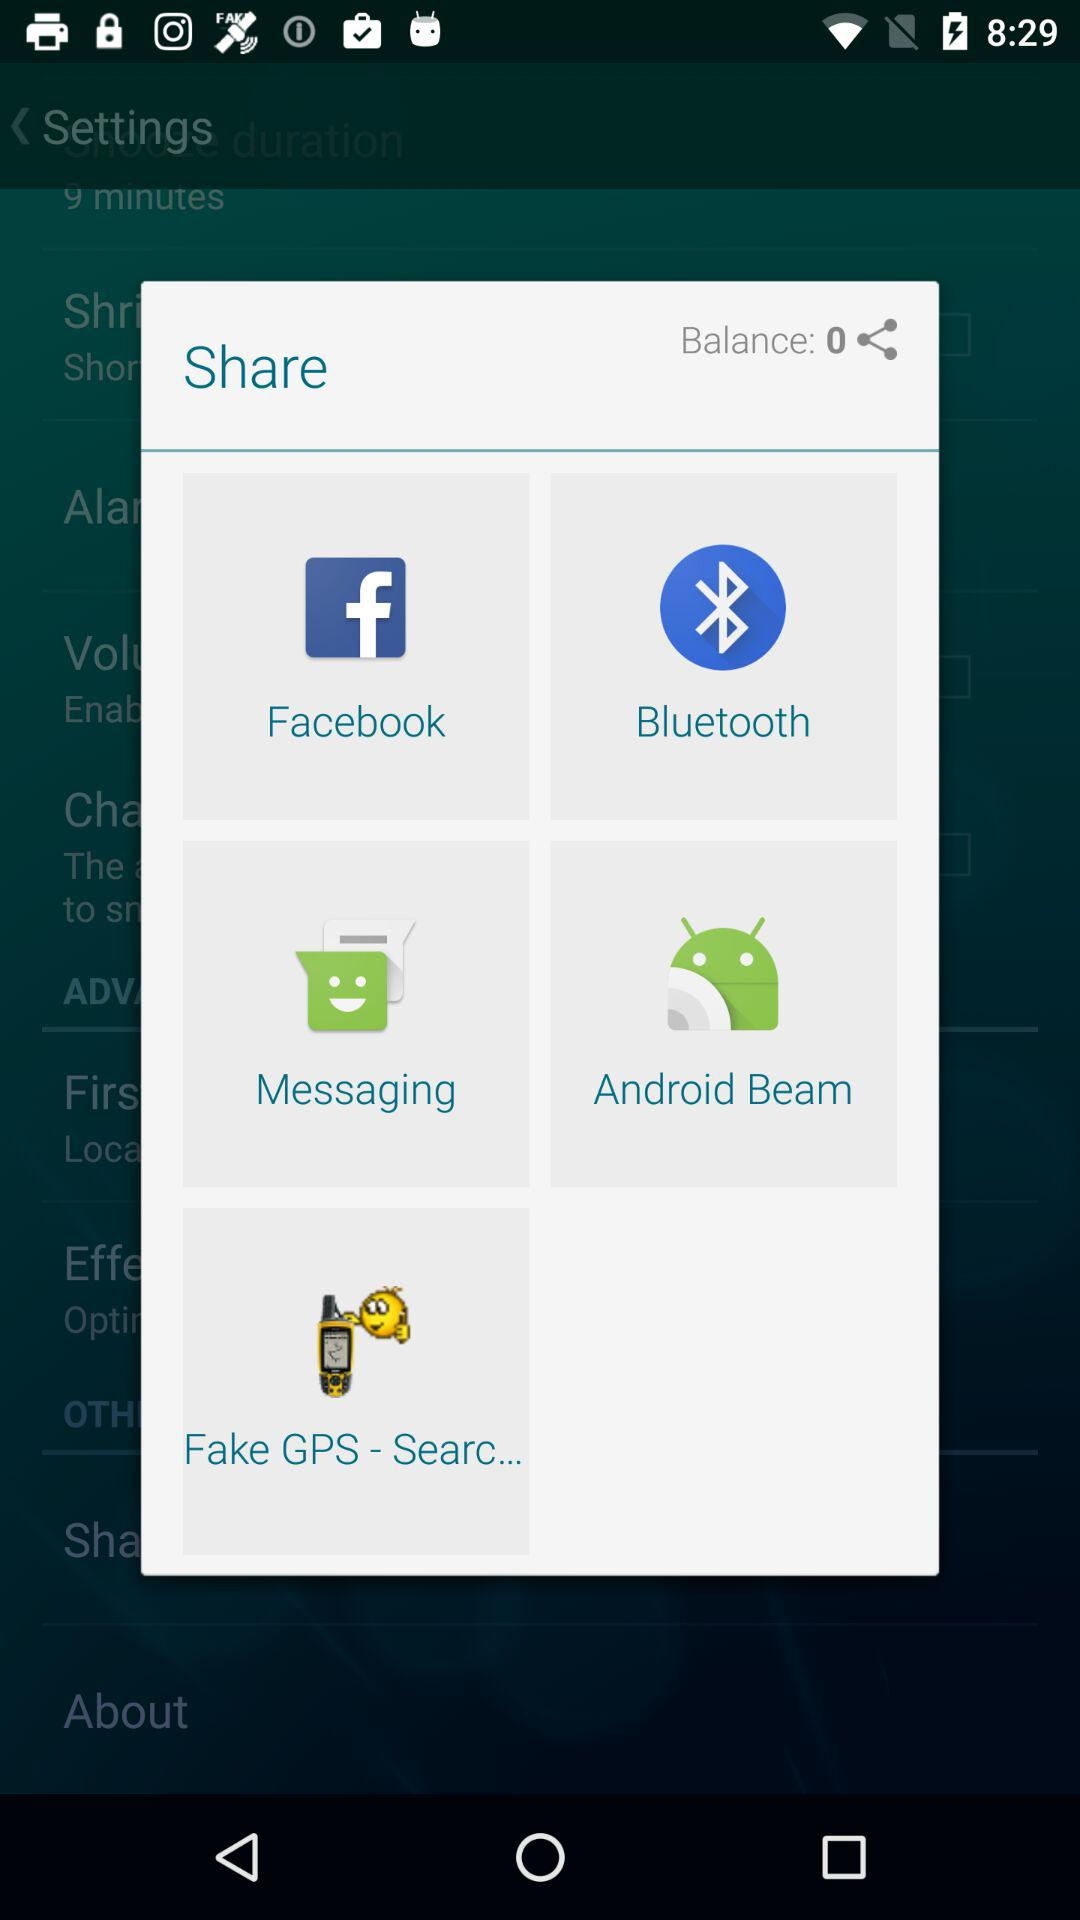What are the sharing options? The sharing options are "Facebook", "Bluetooth", "Messaging", "Android Beam" and "Fake GPS - Searc...". 